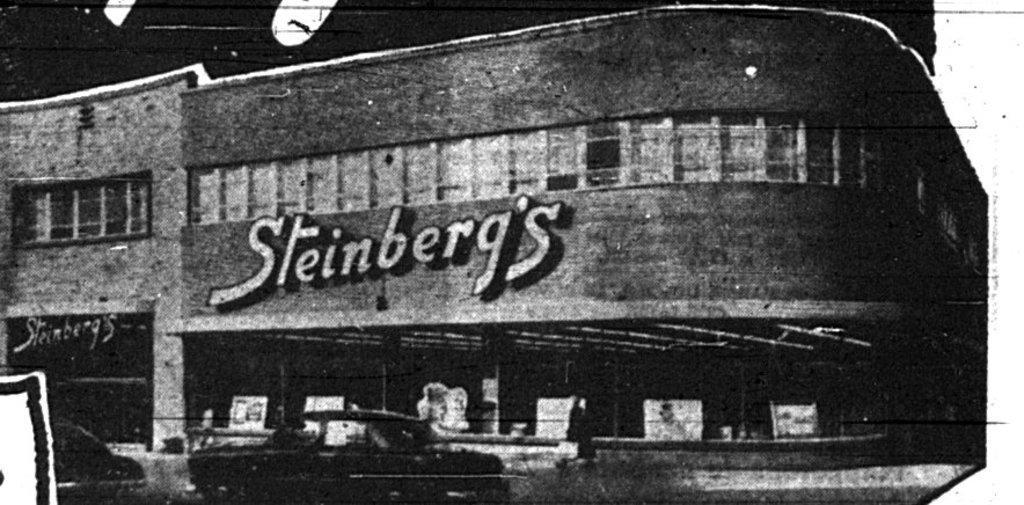Can you describe this image briefly? Here in this picture we can see a poster, on which we can see a building with windows and we can also see a car present on the road. 